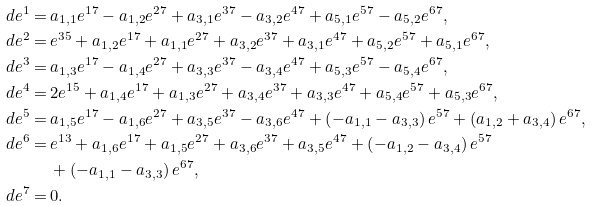Convert formula to latex. <formula><loc_0><loc_0><loc_500><loc_500>d e ^ { 1 } = & \, a _ { 1 , 1 } e ^ { 1 7 } - a _ { 1 , 2 } e ^ { 2 7 } + a _ { 3 , 1 } e ^ { 3 7 } - a _ { 3 , 2 } e ^ { 4 7 } + a _ { 5 , 1 } e ^ { 5 7 } - a _ { 5 , 2 } e ^ { 6 7 } , \\ d e ^ { 2 } = & \, e ^ { 3 5 } + a _ { 1 , 2 } e ^ { 1 7 } + a _ { 1 , 1 } e ^ { 2 7 } + a _ { 3 , 2 } e ^ { 3 7 } + a _ { 3 , 1 } e ^ { 4 7 } + a _ { 5 , 2 } e ^ { 5 7 } + a _ { 5 , 1 } e ^ { 6 7 } , \\ d e ^ { 3 } = & \, a _ { 1 , 3 } e ^ { 1 7 } - a _ { 1 , 4 } e ^ { 2 7 } + a _ { 3 , 3 } e ^ { 3 7 } - a _ { 3 , 4 } e ^ { 4 7 } + a _ { 5 , 3 } e ^ { 5 7 } - a _ { 5 , 4 } e ^ { 6 7 } , \\ d e ^ { 4 } = & \, 2 e ^ { 1 5 } + a _ { 1 , 4 } e ^ { 1 7 } + a _ { 1 , 3 } e ^ { 2 7 } + a _ { 3 , 4 } e ^ { 3 7 } + a _ { 3 , 3 } e ^ { 4 7 } + a _ { 5 , 4 } e ^ { 5 7 } + a _ { 5 , 3 } e ^ { 6 7 } , \\ d e ^ { 5 } = & \, a _ { 1 , 5 } e ^ { 1 7 } - a _ { 1 , 6 } e ^ { 2 7 } + a _ { 3 , 5 } e ^ { 3 7 } - a _ { 3 , 6 } e ^ { 4 7 } + \left ( - a _ { 1 , 1 } - a _ { 3 , 3 } \right ) e ^ { 5 7 } + \left ( a _ { 1 , 2 } + a _ { 3 , 4 } \right ) e ^ { 6 7 } , \\ d e ^ { 6 } = & \, e ^ { 1 3 } + a _ { 1 , 6 } e ^ { 1 7 } + a _ { 1 , 5 } e ^ { 2 7 } + a _ { 3 , 6 } e ^ { 3 7 } + a _ { 3 , 5 } e ^ { 4 7 } + \left ( - a _ { 1 , 2 } - a _ { 3 , 4 } \right ) e ^ { 5 7 } \\ & \, + \left ( - a _ { 1 , 1 } - a _ { 3 , 3 } \right ) e ^ { 6 7 } , \\ d e ^ { 7 } = & \, 0 .</formula> 